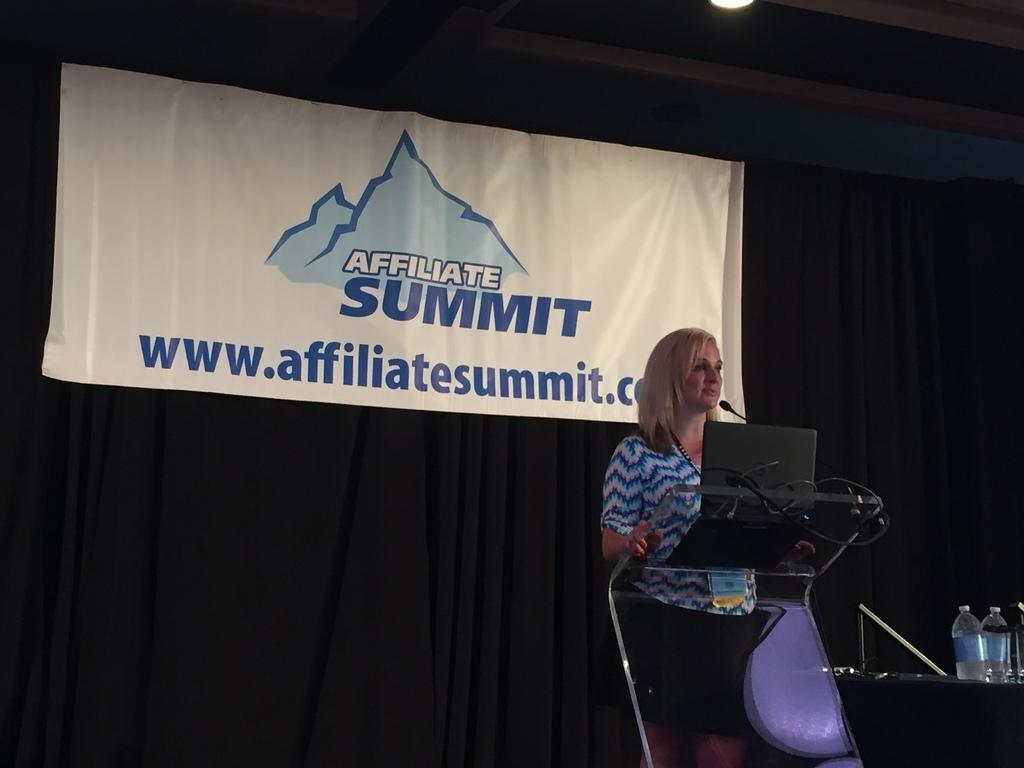<image>
Create a compact narrative representing the image presented. A woman giving a speech at the Affiliate Summit. 